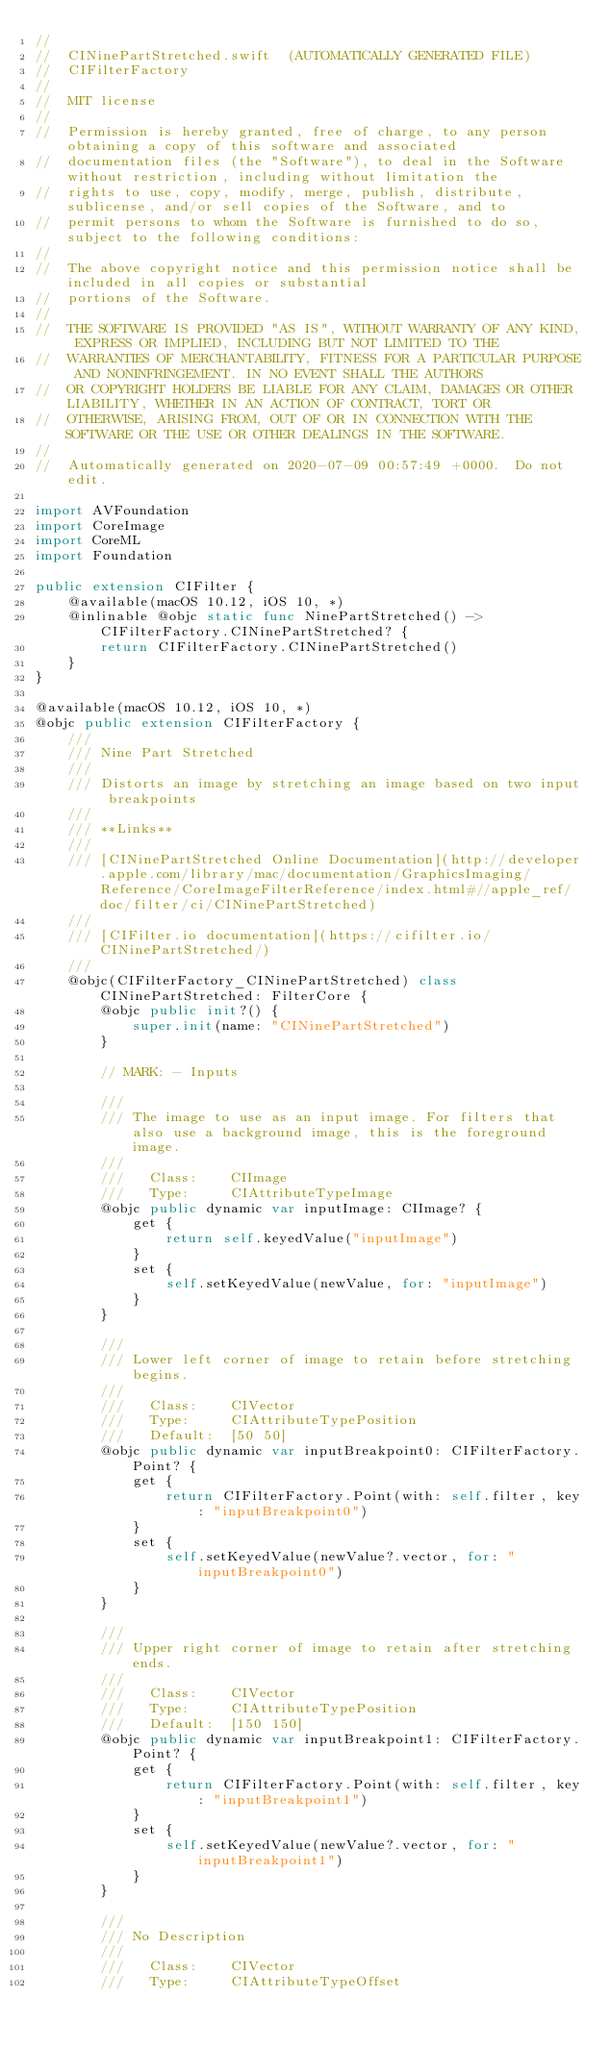Convert code to text. <code><loc_0><loc_0><loc_500><loc_500><_Swift_>//
//  CINinePartStretched.swift  (AUTOMATICALLY GENERATED FILE)
//  CIFilterFactory
//
//  MIT license
//
//  Permission is hereby granted, free of charge, to any person obtaining a copy of this software and associated
//  documentation files (the "Software"), to deal in the Software without restriction, including without limitation the
//  rights to use, copy, modify, merge, publish, distribute, sublicense, and/or sell copies of the Software, and to
//  permit persons to whom the Software is furnished to do so, subject to the following conditions:
//
//  The above copyright notice and this permission notice shall be included in all copies or substantial
//  portions of the Software.
//
//  THE SOFTWARE IS PROVIDED "AS IS", WITHOUT WARRANTY OF ANY KIND, EXPRESS OR IMPLIED, INCLUDING BUT NOT LIMITED TO THE
//  WARRANTIES OF MERCHANTABILITY, FITNESS FOR A PARTICULAR PURPOSE AND NONINFRINGEMENT. IN NO EVENT SHALL THE AUTHORS
//  OR COPYRIGHT HOLDERS BE LIABLE FOR ANY CLAIM, DAMAGES OR OTHER LIABILITY, WHETHER IN AN ACTION OF CONTRACT, TORT OR
//  OTHERWISE, ARISING FROM, OUT OF OR IN CONNECTION WITH THE SOFTWARE OR THE USE OR OTHER DEALINGS IN THE SOFTWARE.
//
//  Automatically generated on 2020-07-09 00:57:49 +0000.  Do not edit.

import AVFoundation
import CoreImage
import CoreML
import Foundation

public extension CIFilter {
	@available(macOS 10.12, iOS 10, *)
	@inlinable @objc static func NinePartStretched() -> CIFilterFactory.CINinePartStretched? {
		return CIFilterFactory.CINinePartStretched()
	}
}

@available(macOS 10.12, iOS 10, *)
@objc public extension CIFilterFactory {
	///
	/// Nine Part Stretched
	///
	/// Distorts an image by stretching an image based on two input breakpoints
	///
	/// **Links**
	///
	/// [CINinePartStretched Online Documentation](http://developer.apple.com/library/mac/documentation/GraphicsImaging/Reference/CoreImageFilterReference/index.html#//apple_ref/doc/filter/ci/CINinePartStretched)
	///
	/// [CIFilter.io documentation](https://cifilter.io/CINinePartStretched/)
	///
	@objc(CIFilterFactory_CINinePartStretched) class CINinePartStretched: FilterCore {
		@objc public init?() {
			super.init(name: "CINinePartStretched")
		}

		// MARK: - Inputs

		///
		/// The image to use as an input image. For filters that also use a background image, this is the foreground image.
		///
		///   Class:    CIImage
		///   Type:     CIAttributeTypeImage
		@objc public dynamic var inputImage: CIImage? {
			get {
				return self.keyedValue("inputImage")
			}
			set {
				self.setKeyedValue(newValue, for: "inputImage")
			}
		}

		///
		/// Lower left corner of image to retain before stretching begins.
		///
		///   Class:    CIVector
		///   Type:     CIAttributeTypePosition
		///   Default:  [50 50]
		@objc public dynamic var inputBreakpoint0: CIFilterFactory.Point? {
			get {
				return CIFilterFactory.Point(with: self.filter, key: "inputBreakpoint0")
			}
			set {
				self.setKeyedValue(newValue?.vector, for: "inputBreakpoint0")
			}
		}

		///
		/// Upper right corner of image to retain after stretching ends.
		///
		///   Class:    CIVector
		///   Type:     CIAttributeTypePosition
		///   Default:  [150 150]
		@objc public dynamic var inputBreakpoint1: CIFilterFactory.Point? {
			get {
				return CIFilterFactory.Point(with: self.filter, key: "inputBreakpoint1")
			}
			set {
				self.setKeyedValue(newValue?.vector, for: "inputBreakpoint1")
			}
		}

		///
		/// No Description
		///
		///   Class:    CIVector
		///   Type:     CIAttributeTypeOffset</code> 